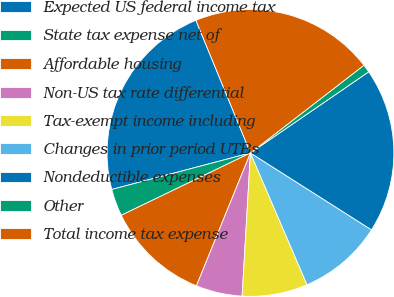Convert chart to OTSL. <chart><loc_0><loc_0><loc_500><loc_500><pie_chart><fcel>Expected US federal income tax<fcel>State tax expense net of<fcel>Affordable housing<fcel>Non-US tax rate differential<fcel>Tax-exempt income including<fcel>Changes in prior period UTBs<fcel>Nondeductible expenses<fcel>Other<fcel>Total income tax expense<nl><fcel>22.89%<fcel>3.06%<fcel>11.7%<fcel>5.22%<fcel>7.38%<fcel>9.54%<fcel>18.58%<fcel>0.9%<fcel>20.74%<nl></chart> 